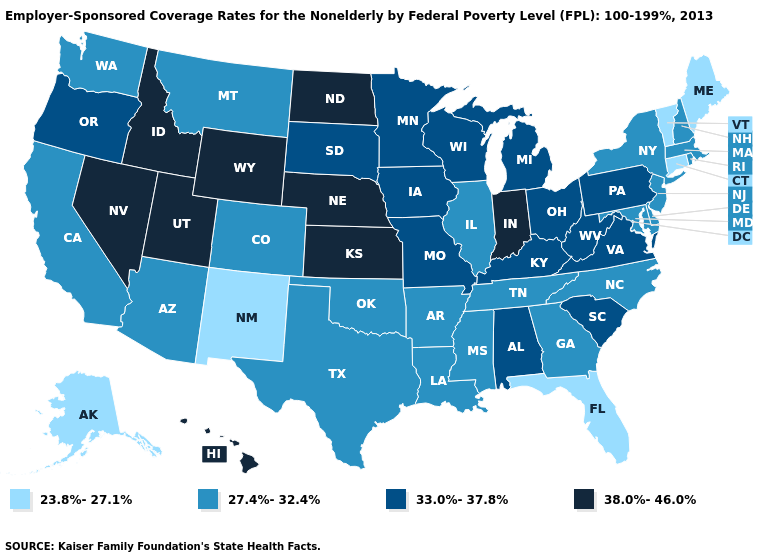What is the lowest value in states that border Kansas?
Give a very brief answer. 27.4%-32.4%. Among the states that border Idaho , does Nevada have the highest value?
Quick response, please. Yes. What is the value of North Carolina?
Answer briefly. 27.4%-32.4%. What is the value of Iowa?
Keep it brief. 33.0%-37.8%. Which states have the lowest value in the Northeast?
Quick response, please. Connecticut, Maine, Vermont. Is the legend a continuous bar?
Keep it brief. No. Does Idaho have the same value as Indiana?
Short answer required. Yes. What is the highest value in the South ?
Short answer required. 33.0%-37.8%. What is the value of Maine?
Quick response, please. 23.8%-27.1%. Does the first symbol in the legend represent the smallest category?
Write a very short answer. Yes. What is the value of Hawaii?
Write a very short answer. 38.0%-46.0%. What is the value of New York?
Write a very short answer. 27.4%-32.4%. What is the value of Maine?
Give a very brief answer. 23.8%-27.1%. Does Nevada have the same value as Kansas?
Write a very short answer. Yes. 